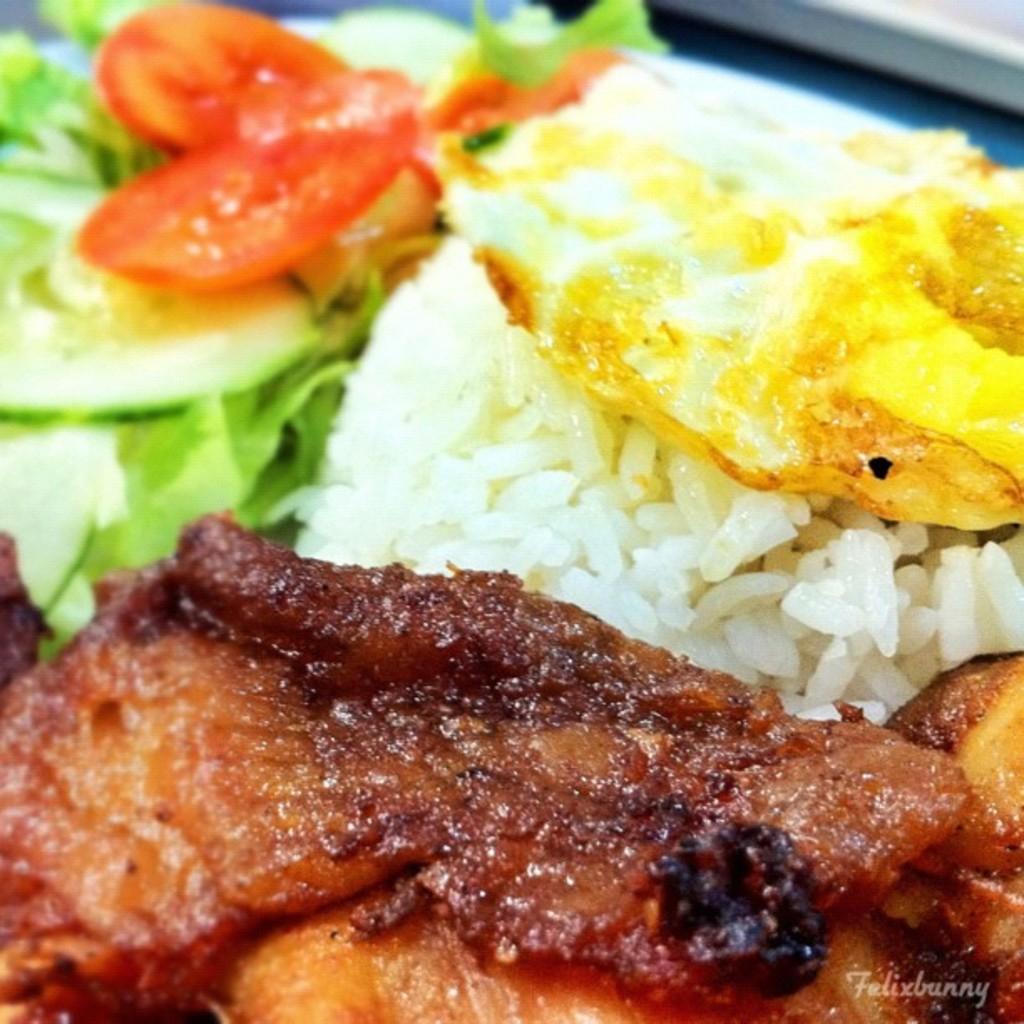Could you give a brief overview of what you see in this image? In this image I can see the food in brown, white, yellow, red and green color. 